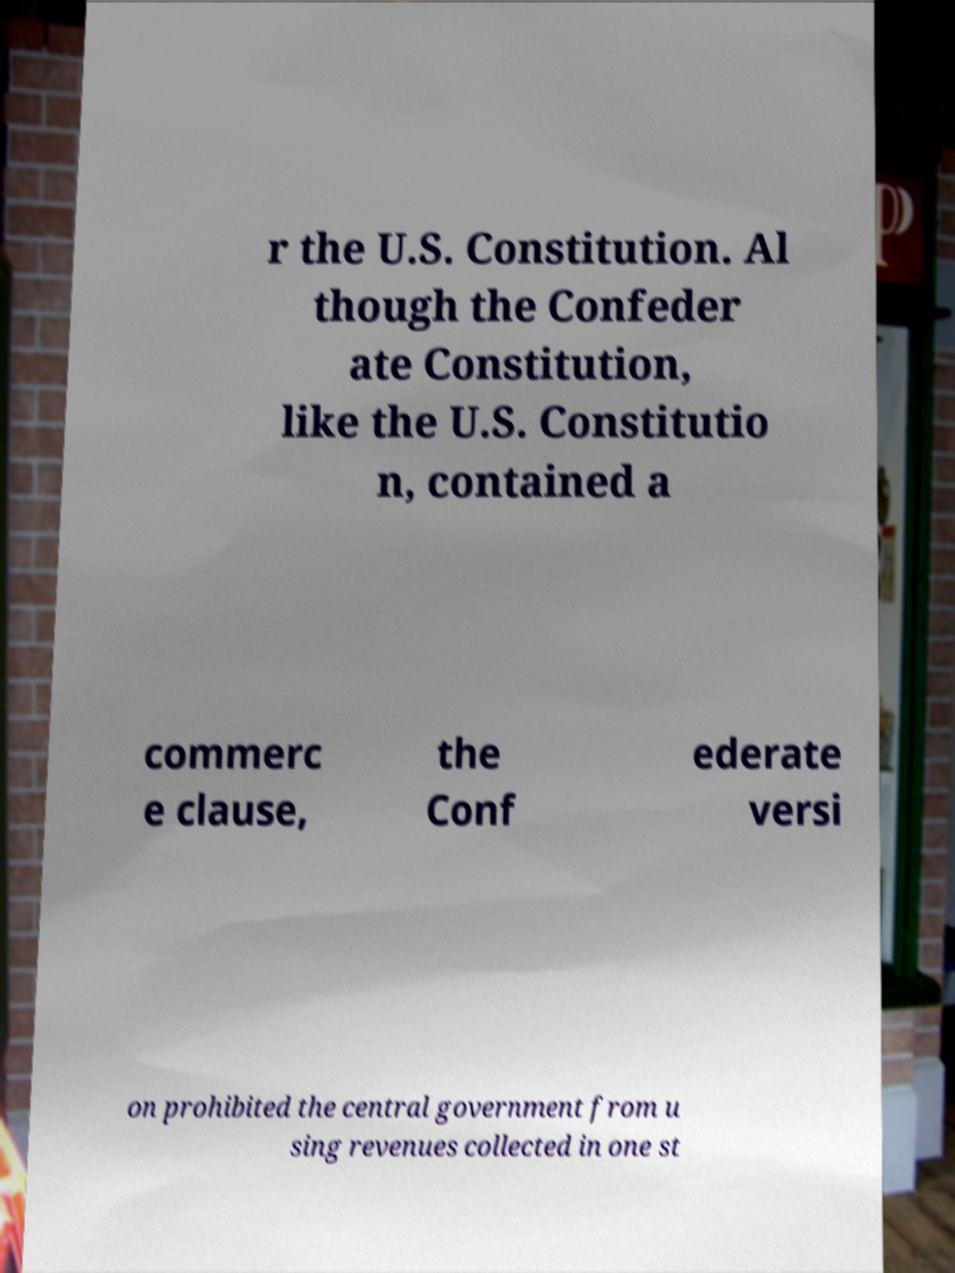For documentation purposes, I need the text within this image transcribed. Could you provide that? r the U.S. Constitution. Al though the Confeder ate Constitution, like the U.S. Constitutio n, contained a commerc e clause, the Conf ederate versi on prohibited the central government from u sing revenues collected in one st 